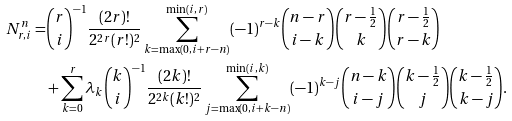<formula> <loc_0><loc_0><loc_500><loc_500>N _ { r , i } ^ { n } = & \binom { r } { i } ^ { - 1 } \frac { ( 2 r ) ! } { 2 ^ { 2 r } ( r ! ) ^ { 2 } } \sum _ { k = \max ( 0 , i + r - n ) } ^ { \min ( i , r ) } ( - 1 ) ^ { r - k } \binom { n - r } { i - k } \binom { r - \frac { 1 } { 2 } } { k } \binom { r - \frac { 1 } { 2 } } { r - k } \\ & + \sum _ { k = 0 } ^ { r } \lambda _ { k } \binom { k } { i } ^ { - 1 } \frac { ( 2 k ) ! } { 2 ^ { 2 k } ( k ! ) ^ { 2 } } \sum _ { j = \max ( 0 , i + k - n ) } ^ { \min ( i , k ) } ( - 1 ) ^ { k - j } \binom { n - k } { i - j } \binom { k - \frac { 1 } { 2 } } { j } \binom { k - \frac { 1 } { 2 } } { k - j } .</formula> 